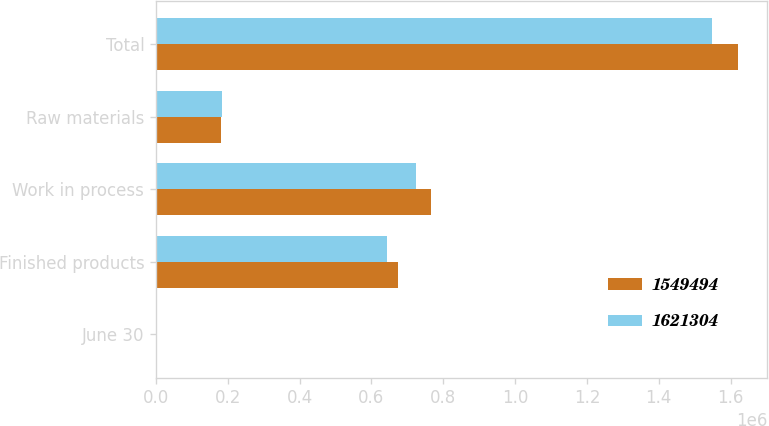<chart> <loc_0><loc_0><loc_500><loc_500><stacked_bar_chart><ecel><fcel>June 30<fcel>Finished products<fcel>Work in process<fcel>Raw materials<fcel>Total<nl><fcel>1.54949e+06<fcel>2018<fcel>673323<fcel>765835<fcel>182146<fcel>1.6213e+06<nl><fcel>1.6213e+06<fcel>2017<fcel>642788<fcel>723133<fcel>183573<fcel>1.54949e+06<nl></chart> 